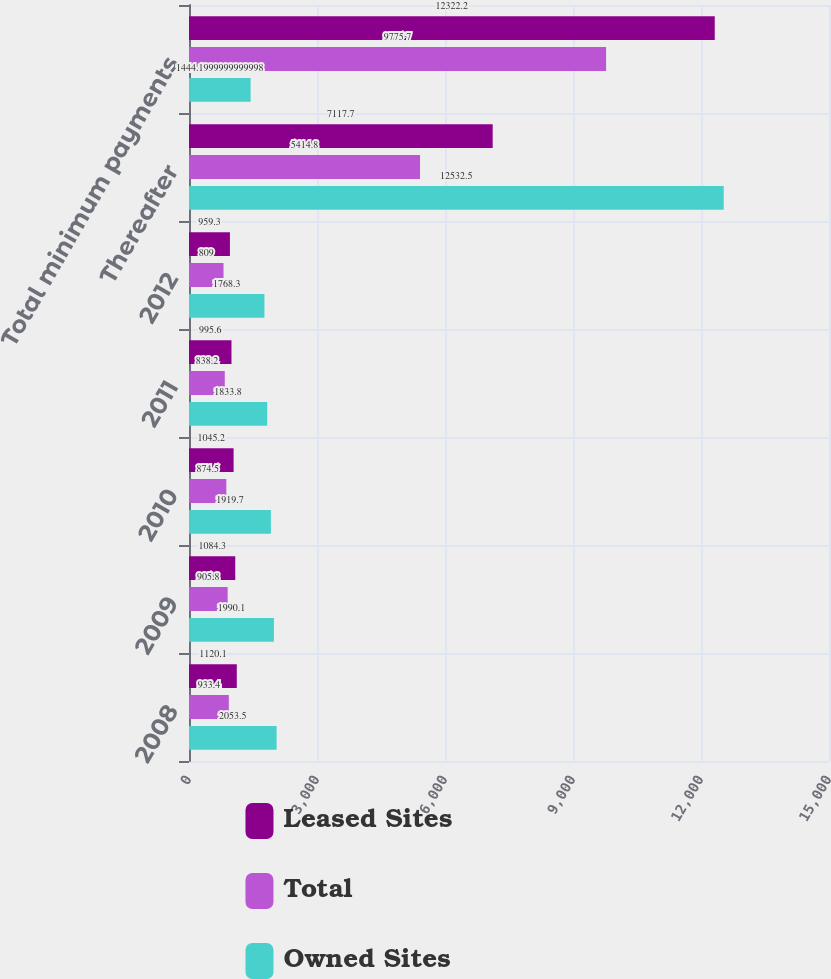<chart> <loc_0><loc_0><loc_500><loc_500><stacked_bar_chart><ecel><fcel>2008<fcel>2009<fcel>2010<fcel>2011<fcel>2012<fcel>Thereafter<fcel>Total minimum payments<nl><fcel>Leased Sites<fcel>1120.1<fcel>1084.3<fcel>1045.2<fcel>995.6<fcel>959.3<fcel>7117.7<fcel>12322.2<nl><fcel>Total<fcel>933.4<fcel>905.8<fcel>874.5<fcel>838.2<fcel>809<fcel>5414.8<fcel>9775.7<nl><fcel>Owned Sites<fcel>2053.5<fcel>1990.1<fcel>1919.7<fcel>1833.8<fcel>1768.3<fcel>12532.5<fcel>1444.2<nl></chart> 